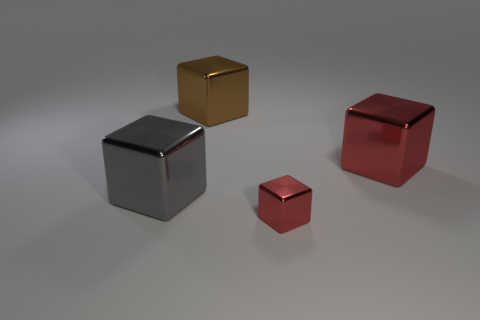Are there any other things that are the same material as the big brown cube?
Your answer should be very brief. Yes. What is the material of the other object that is the same color as the tiny metallic thing?
Give a very brief answer. Metal. What number of other things are the same color as the small shiny thing?
Offer a terse response. 1. How many things are either green rubber things or big brown things?
Your answer should be compact. 1. There is a shiny thing behind the big red thing; how big is it?
Give a very brief answer. Large. There is a big metallic object that is behind the metallic thing that is right of the tiny red cube; what number of red blocks are behind it?
Your response must be concise. 0. What number of objects are on the right side of the brown cube and in front of the large red cube?
Your answer should be compact. 1. Are there fewer large metal objects that are to the left of the gray cube than small blocks that are behind the big red thing?
Make the answer very short. No. The brown object has what shape?
Your response must be concise. Cube. Are there more metal objects right of the brown thing than small shiny objects in front of the small cube?
Provide a short and direct response. Yes. 